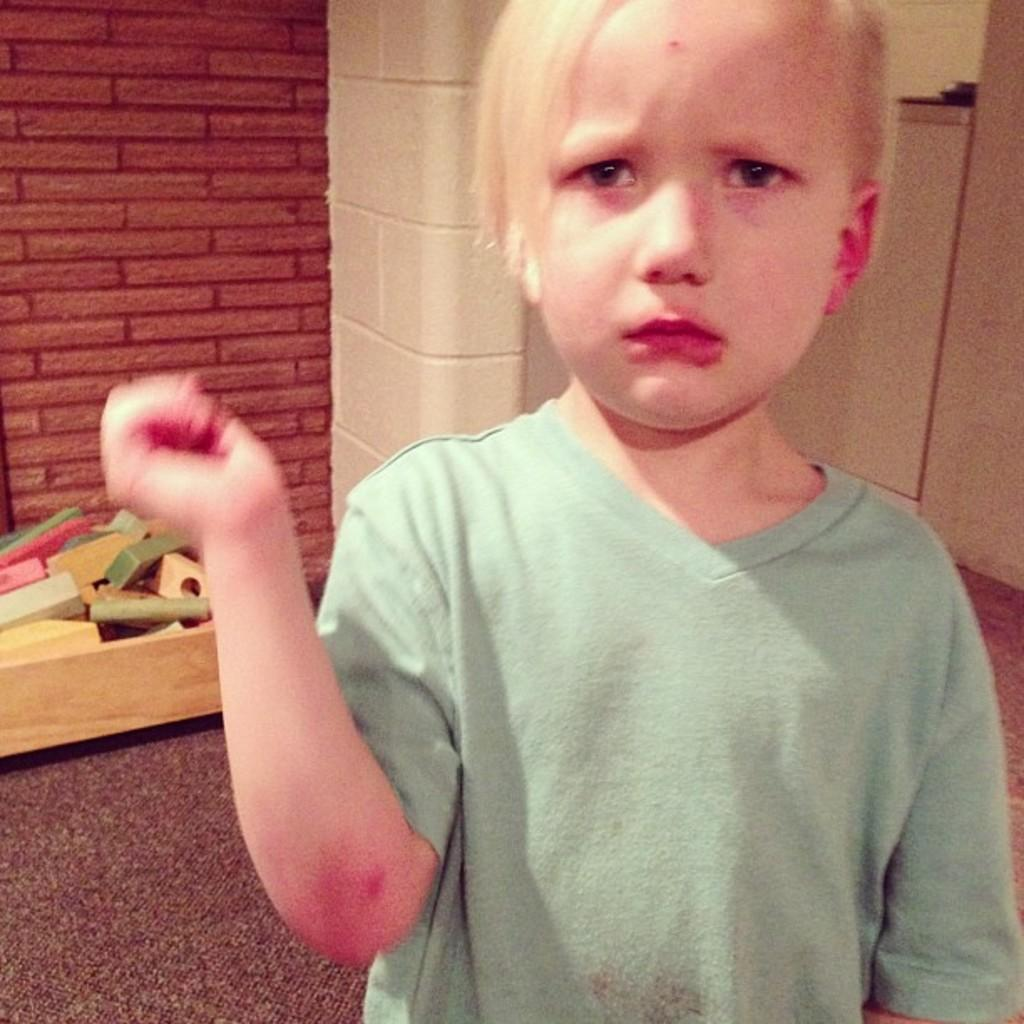What is the main subject of the image? There is a boy in the image. What is the boy wearing? The boy is wearing a green T-shirt. Can you describe the background of the image? There are objects behind the boy, and there is a red wall in the image. What type of government is depicted in the image? There is no depiction of a government in the image; it features a boy wearing a green T-shirt with objects and a red wall in the background. Can you tell me how many bears are visible in the image? There are no bears present in the image. 